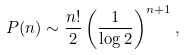Convert formula to latex. <formula><loc_0><loc_0><loc_500><loc_500>P ( n ) \sim \frac { n ! } { 2 } \left ( \frac { 1 } { \log 2 } \right ) ^ { n + 1 } ,</formula> 